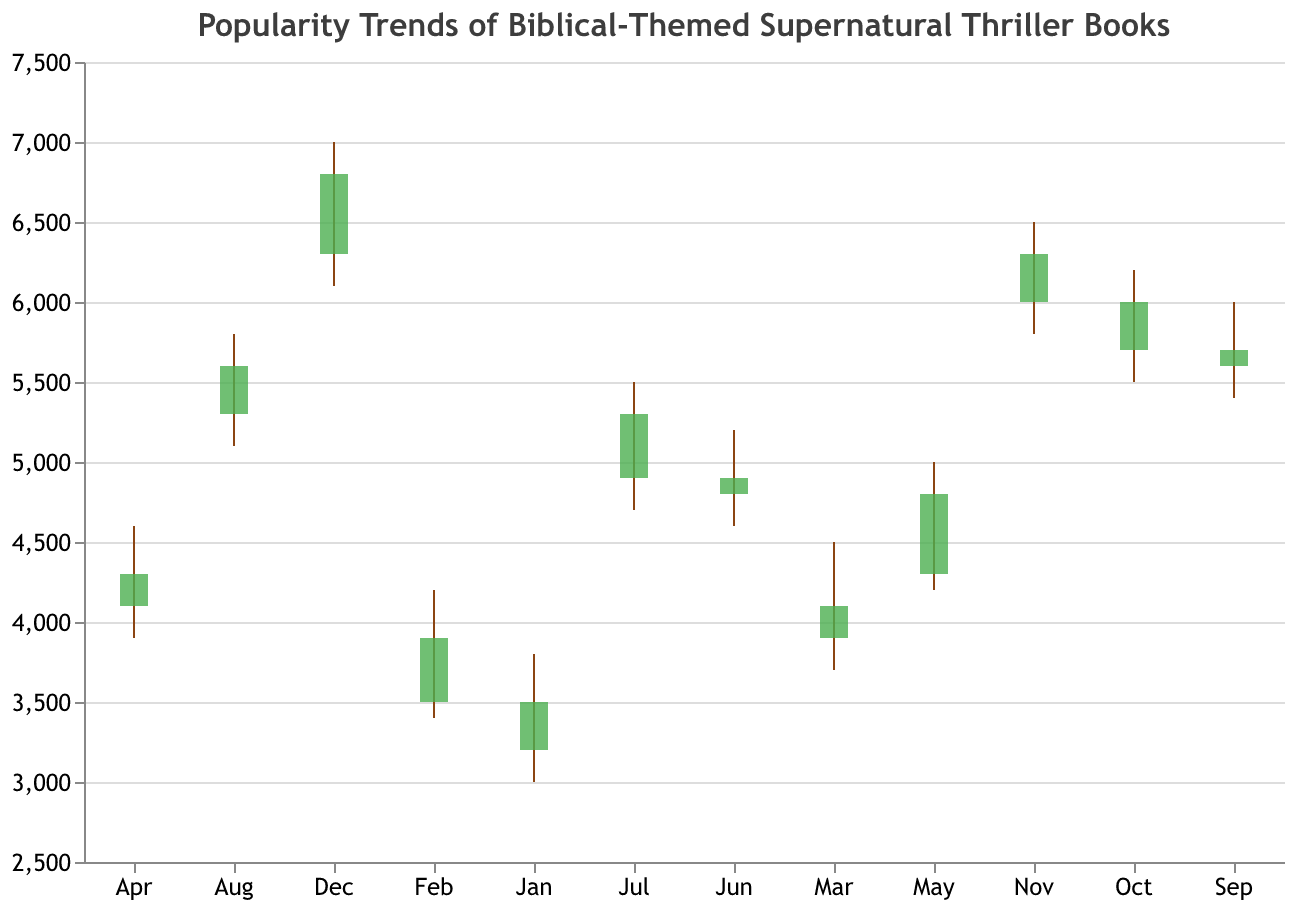What's the title of the chart? The title of the chart is prominently displayed at the top. It reads "Popularity Trends of Biblical-Themed Supernatural Thriller Books".
Answer: Popularity Trends of Biblical-Themed Supernatural Thriller Books What are the highest and lowest popularity scores in February? Referring to the February data, the highest popularity score ("High") is 4200 and the lowest score ("Low") is 3400.
Answer: 4200 and 3400 In which month did the popularity score open at 4900? Checking the data points for the 'Open' column, it is observed that July is the month in which the popularity score opened at 4900.
Answer: July Which month had the biggest range in popularity scores? To find the range, subtract the 'Low' value from the 'High' value for each month. The biggest range is in December: 7000 - 6100 = 900 points.
Answer: December How many months saw a closing value above 6000? From the data, the months with closing values above 6000 are: October (6000), November (6300), and December (6800). Counting them gives a total of 3 months.
Answer: 3 Which month had the lowest closing value? By comparing the 'Close' values for each month, the lowest closing value is found in January at 3500.
Answer: January Was the closing value in May higher or lower than the opening value in June? The closing value in May is 4800, and the opening value in June is also 4800. Since they are equal, it's neither higher nor lower.
Answer: Equal What is the average closing value over all the months? Sum the closing values and divide by the number of months: (3500 + 3900 + 4100 + 4300 + 4800 + 4900 + 5300 + 5600 + 5700 + 6000 + 6300 + 6800) / 12 = 5050.
Answer: 5050 Compare the opening and closing trends from January to December. Analyzing the 'Open' and 'Close' values from January to December shows an overall upward trend, with January starting at 3200 (Open) and 3500 (Close) and December ending at 6300 (Open) and 6800 (Close).
Answer: Upward trend Which months experienced an increase in popularity (close > open)? Look at the months where the 'Close' value is higher than the 'Open' value: January (3500 > 3200), February (3900 > 3500), March (4100 > 3900), April (4300 > 4100), May (4800 > 4300), July (5300 > 4900), August (5600 > 5300), September (5700 > 5600), October (6000 > 5700), November (6300 > 6000), and December (6800 > 6300). These are 11 months.
Answer: 11 